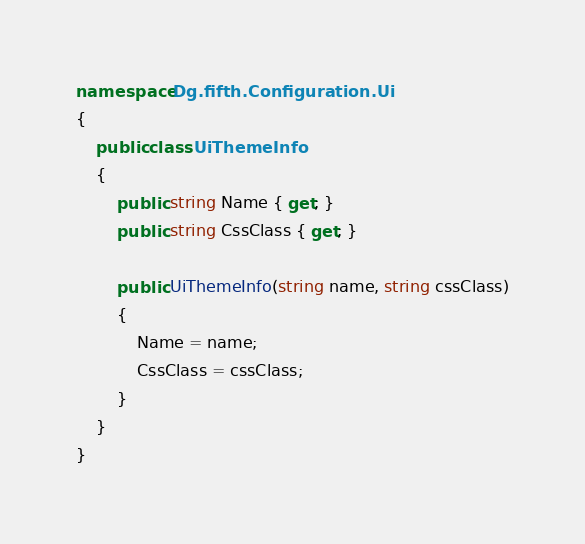Convert code to text. <code><loc_0><loc_0><loc_500><loc_500><_C#_>namespace Dg.fifth.Configuration.Ui
{
    public class UiThemeInfo
    {
        public string Name { get; }
        public string CssClass { get; }

        public UiThemeInfo(string name, string cssClass)
        {
            Name = name;
            CssClass = cssClass;
        }
    }
}
</code> 